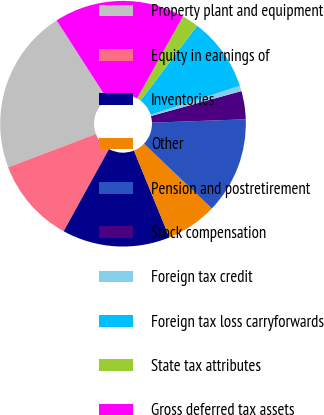<chart> <loc_0><loc_0><loc_500><loc_500><pie_chart><fcel>Property plant and equipment<fcel>Equity in earnings of<fcel>Inventories<fcel>Other<fcel>Pension and postretirement<fcel>Stock compensation<fcel>Foreign tax credit<fcel>Foreign tax loss carryforwards<fcel>State tax attributes<fcel>Gross deferred tax assets<nl><fcel>21.69%<fcel>11.2%<fcel>14.2%<fcel>6.7%<fcel>12.7%<fcel>3.71%<fcel>0.71%<fcel>9.7%<fcel>2.21%<fcel>17.19%<nl></chart> 